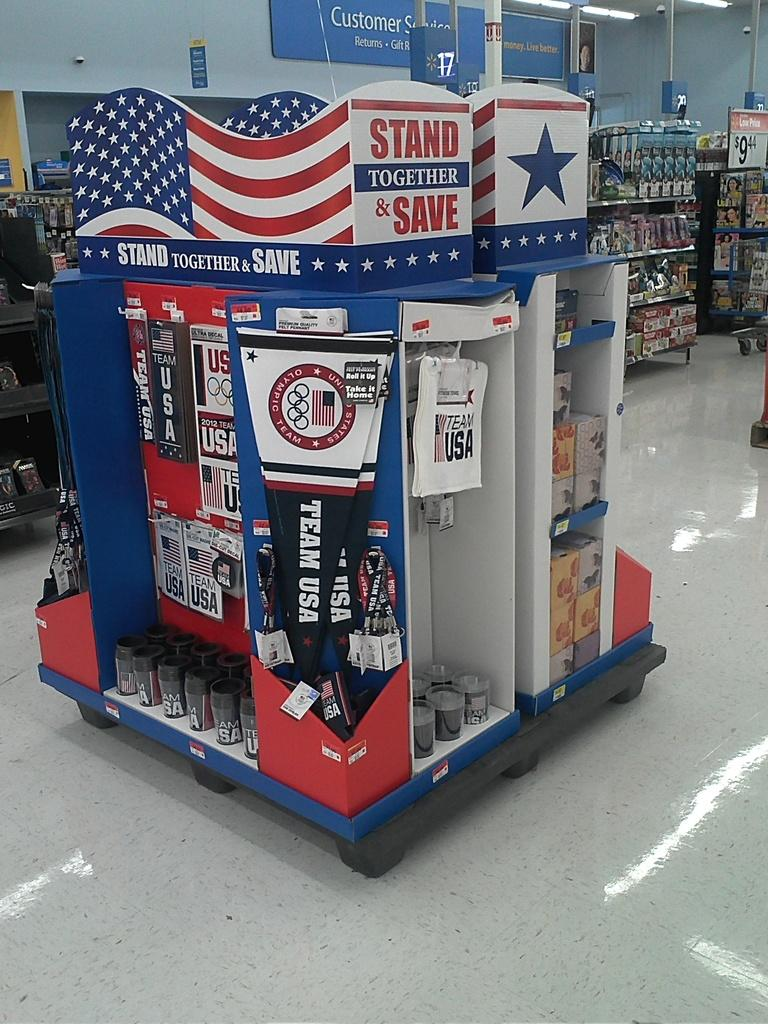<image>
Create a compact narrative representing the image presented. A store display features Team USA Olympic souvenirs. 